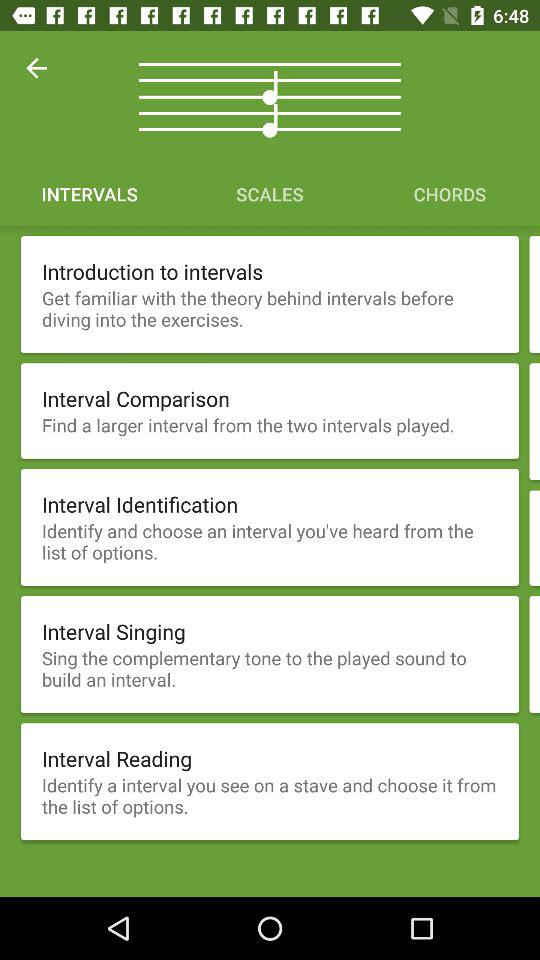How many exercises are there in total in the Intervals section?
Answer the question using a single word or phrase. 5 